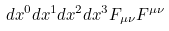<formula> <loc_0><loc_0><loc_500><loc_500>d x ^ { 0 } d x ^ { 1 } d x ^ { 2 } d x ^ { 3 } F _ { \mu \nu } F ^ { \mu \nu }</formula> 